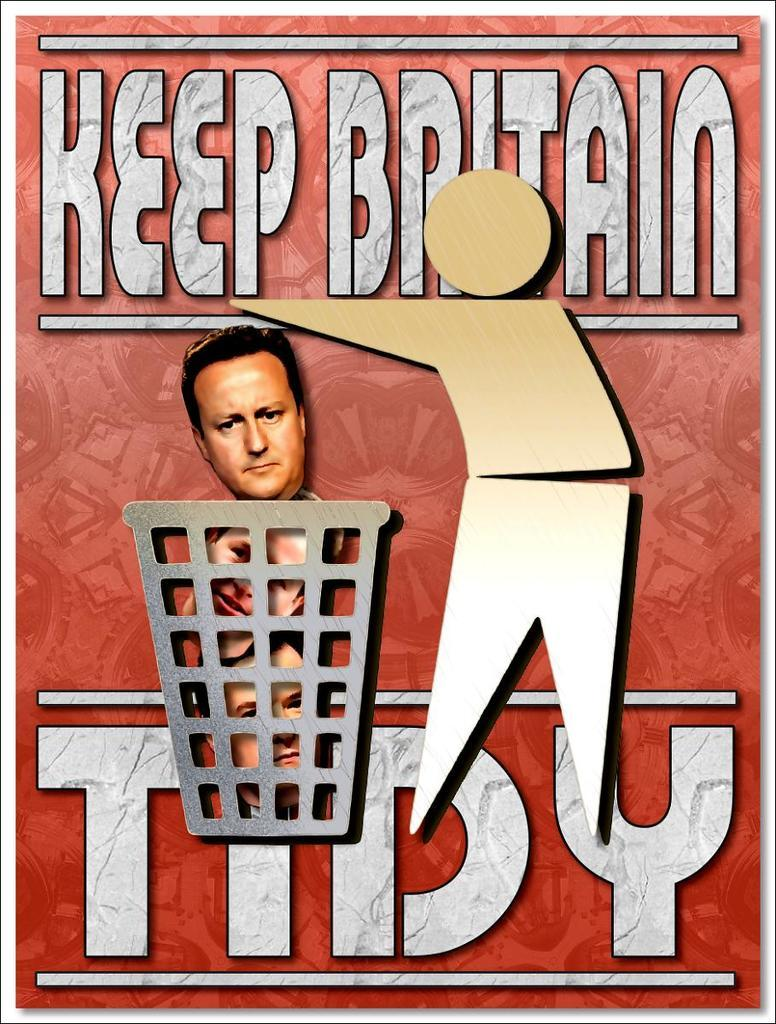What type of visual is the image? The image is a poster. How many faces of persons are depicted in the poster? There are faces of three persons in the poster. What is the unusual situation with the faces in the poster? The faces appear to be thrown into a dustbin. Can you describe the person on the right side of the poster? There is a person on the right side of the poster. What else is present in the poster besides the faces and the person? There is text in the poster. How much money is being exchanged between the faces in the poster? There is no money exchange depicted in the poster; the faces are thrown into a dustbin. What type of chess piece is being used as a decoration in the poster? There is no chess piece present in the poster; it features faces and a person. 